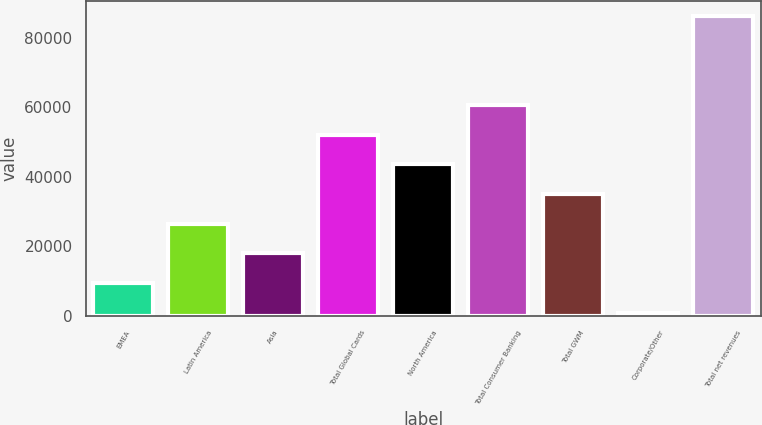Convert chart. <chart><loc_0><loc_0><loc_500><loc_500><bar_chart><fcel>EMEA<fcel>Latin America<fcel>Asia<fcel>Total Global Cards<fcel>North America<fcel>Total Consumer Banking<fcel>Total GWM<fcel>Corporate/Other<fcel>Total net revenues<nl><fcel>9482.3<fcel>26558.9<fcel>18020.6<fcel>52173.8<fcel>43635.5<fcel>60712.1<fcel>35097.2<fcel>944<fcel>86327<nl></chart> 